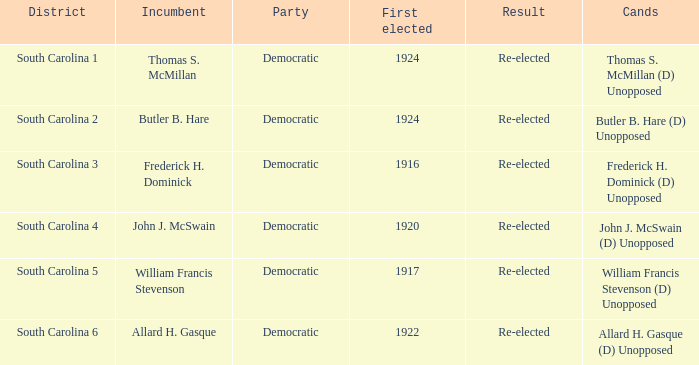What is the total number of results where the district is south carolina 5? 1.0. 